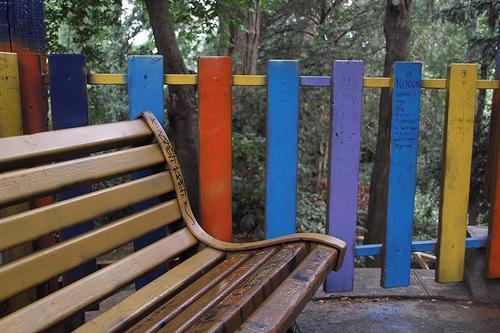How many benches are there?
Give a very brief answer. 1. 